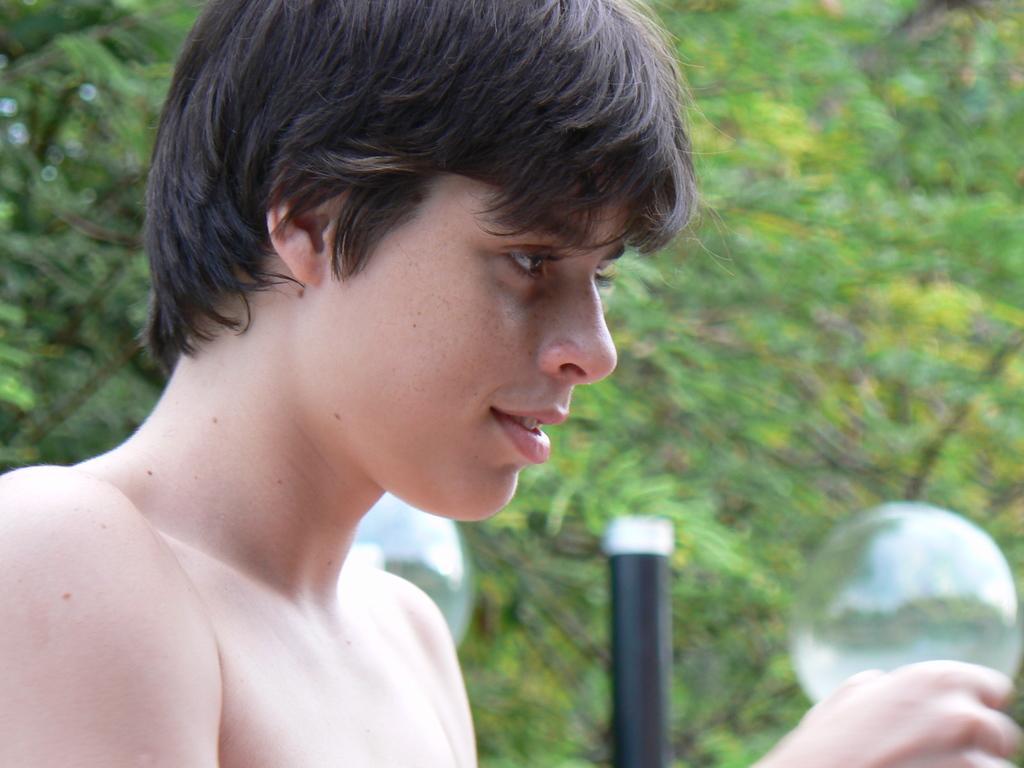Please provide a concise description of this image. In this image there is a person and there are a few bubbles in the air. In the background there is a rod and trees. 